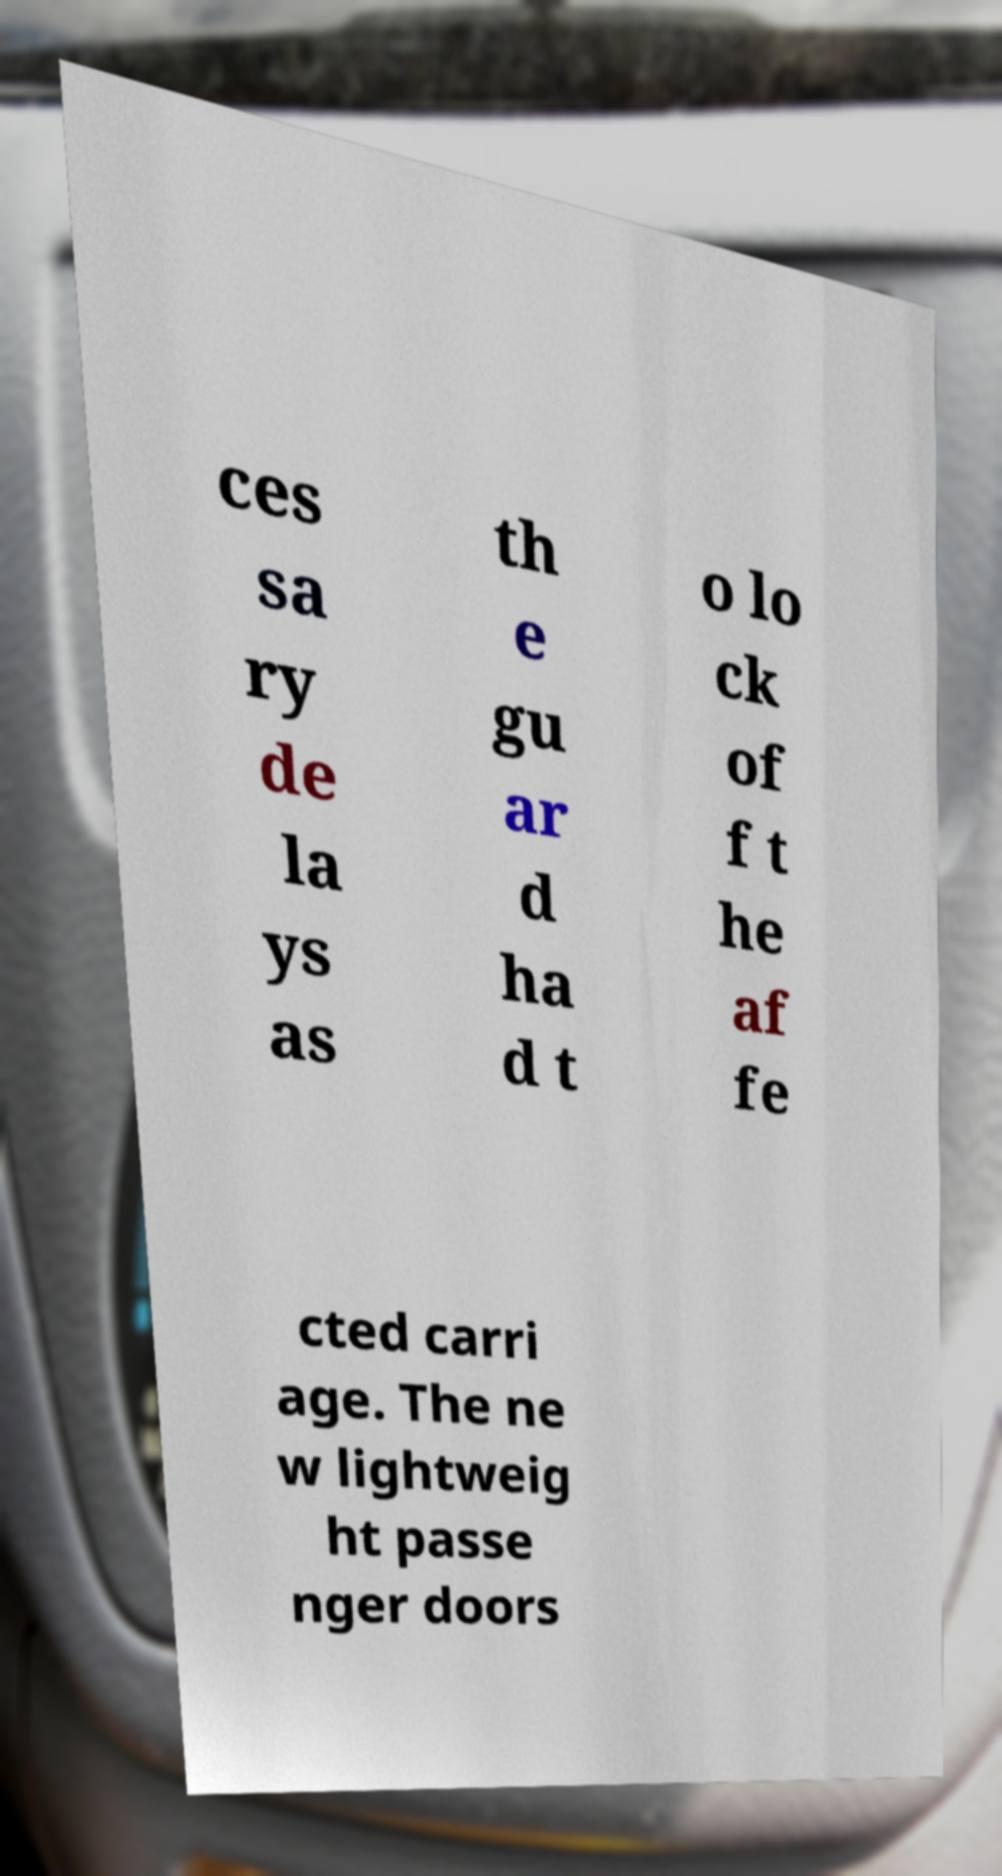I need the written content from this picture converted into text. Can you do that? ces sa ry de la ys as th e gu ar d ha d t o lo ck of f t he af fe cted carri age. The ne w lightweig ht passe nger doors 